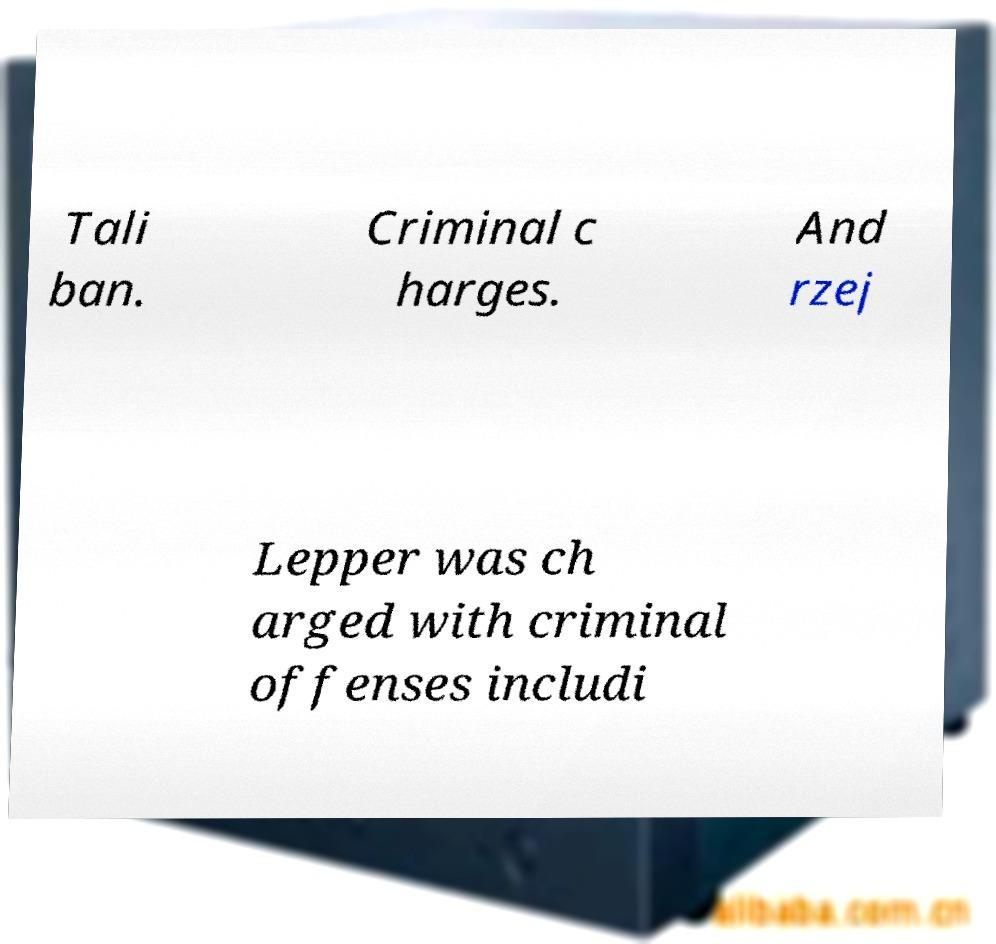Can you read and provide the text displayed in the image?This photo seems to have some interesting text. Can you extract and type it out for me? Tali ban. Criminal c harges. And rzej Lepper was ch arged with criminal offenses includi 